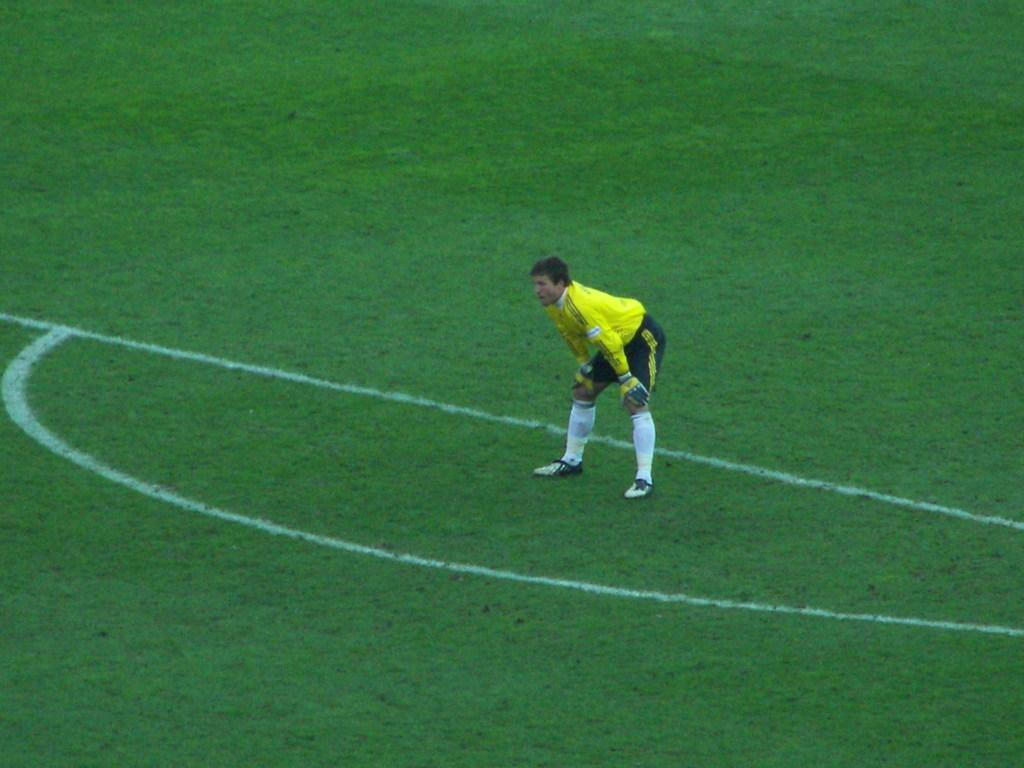What is the main subject of the image? There is a player in the image. What is the player wearing? The player is wearing a yellow t-shirt. Where is the player located in the image? The player is standing in the middle of a field. Is there a payment system visible in the image? There is no payment system present in the image; it features a player standing in a field. Can you see a nest in the image? There is no nest visible in the image; it only shows a player wearing a yellow t-shirt and standing in a field. 